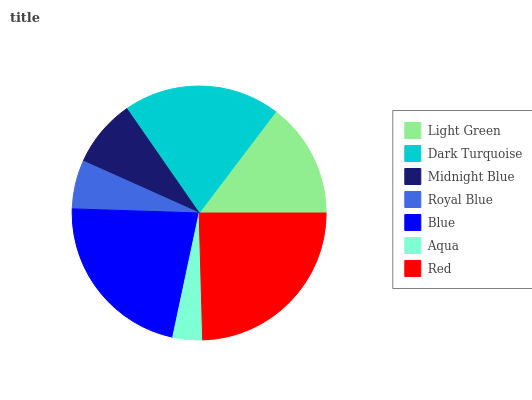Is Aqua the minimum?
Answer yes or no. Yes. Is Red the maximum?
Answer yes or no. Yes. Is Dark Turquoise the minimum?
Answer yes or no. No. Is Dark Turquoise the maximum?
Answer yes or no. No. Is Dark Turquoise greater than Light Green?
Answer yes or no. Yes. Is Light Green less than Dark Turquoise?
Answer yes or no. Yes. Is Light Green greater than Dark Turquoise?
Answer yes or no. No. Is Dark Turquoise less than Light Green?
Answer yes or no. No. Is Light Green the high median?
Answer yes or no. Yes. Is Light Green the low median?
Answer yes or no. Yes. Is Blue the high median?
Answer yes or no. No. Is Dark Turquoise the low median?
Answer yes or no. No. 